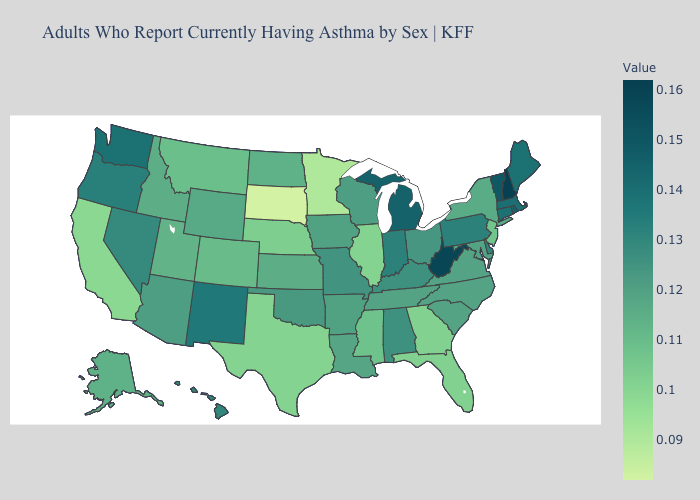Does Maryland have the highest value in the South?
Keep it brief. No. Among the states that border Tennessee , which have the highest value?
Be succinct. Alabama, Kentucky. Among the states that border Connecticut , does Rhode Island have the highest value?
Give a very brief answer. Yes. Which states have the lowest value in the Northeast?
Keep it brief. New Jersey. 